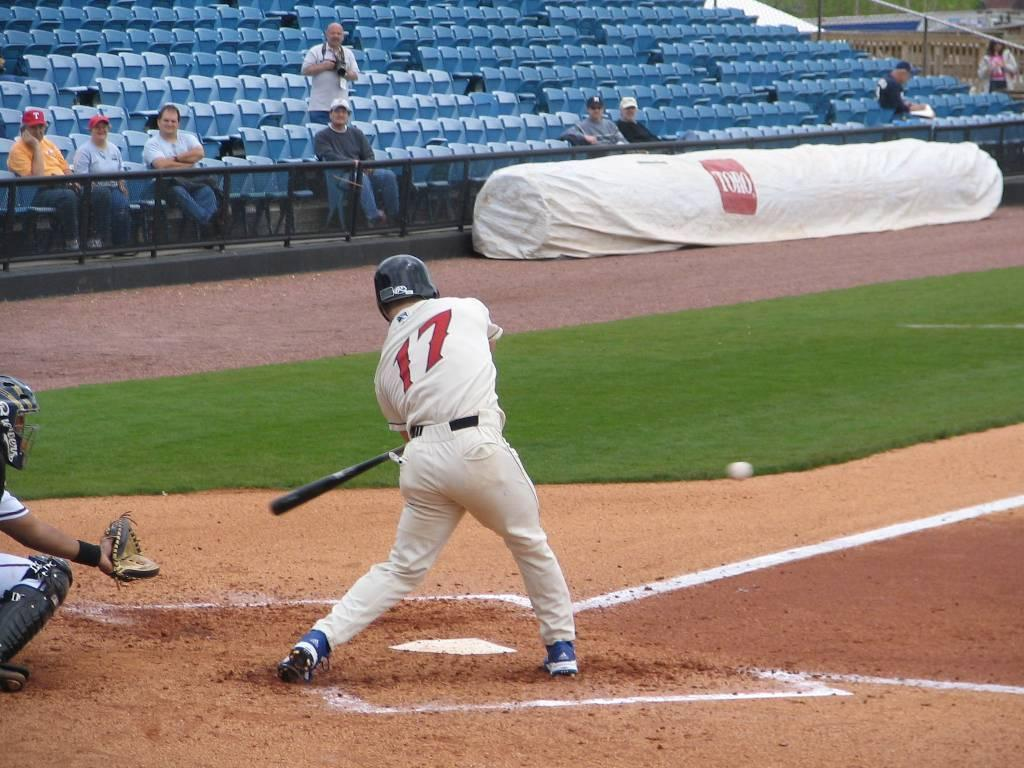<image>
Create a compact narrative representing the image presented. A person readies to hit a ball as they wear 17 